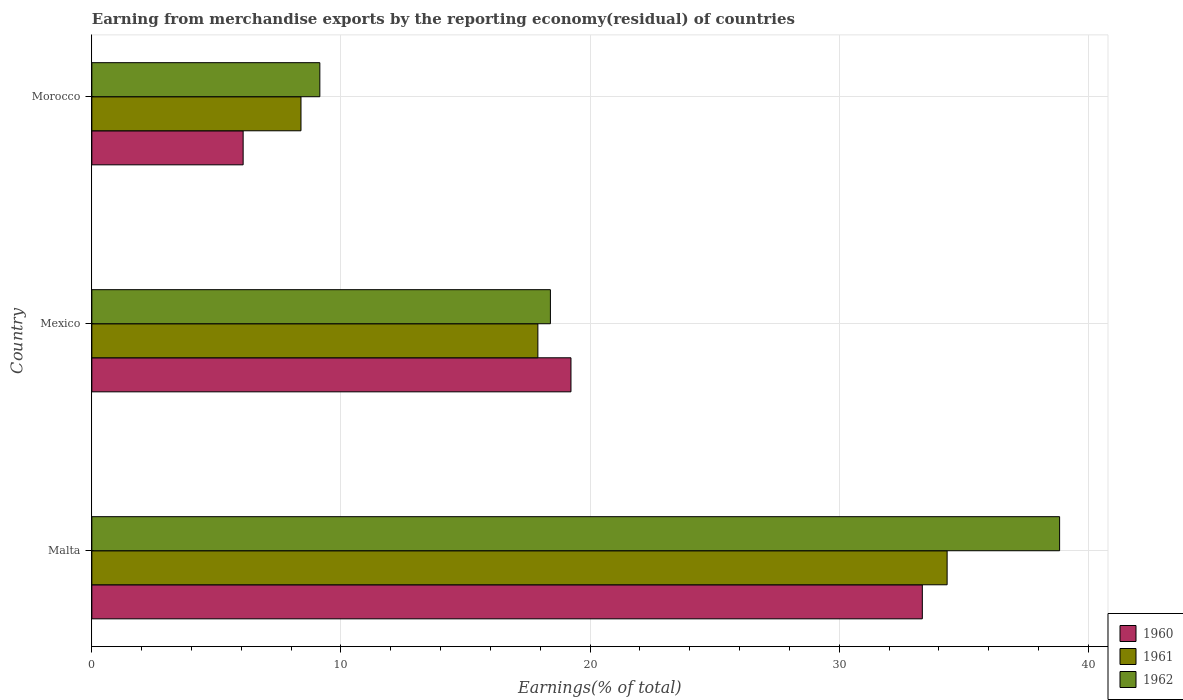How many different coloured bars are there?
Your answer should be compact. 3. Are the number of bars per tick equal to the number of legend labels?
Your answer should be very brief. Yes. Are the number of bars on each tick of the Y-axis equal?
Your answer should be compact. Yes. How many bars are there on the 1st tick from the bottom?
Keep it short and to the point. 3. What is the label of the 3rd group of bars from the top?
Give a very brief answer. Malta. In how many cases, is the number of bars for a given country not equal to the number of legend labels?
Provide a short and direct response. 0. What is the percentage of amount earned from merchandise exports in 1961 in Morocco?
Offer a very short reply. 8.39. Across all countries, what is the maximum percentage of amount earned from merchandise exports in 1960?
Your response must be concise. 33.33. Across all countries, what is the minimum percentage of amount earned from merchandise exports in 1962?
Keep it short and to the point. 9.15. In which country was the percentage of amount earned from merchandise exports in 1960 maximum?
Your answer should be very brief. Malta. In which country was the percentage of amount earned from merchandise exports in 1961 minimum?
Keep it short and to the point. Morocco. What is the total percentage of amount earned from merchandise exports in 1960 in the graph?
Ensure brevity in your answer.  58.64. What is the difference between the percentage of amount earned from merchandise exports in 1960 in Mexico and that in Morocco?
Your response must be concise. 13.16. What is the difference between the percentage of amount earned from merchandise exports in 1962 in Malta and the percentage of amount earned from merchandise exports in 1960 in Morocco?
Your answer should be compact. 32.77. What is the average percentage of amount earned from merchandise exports in 1961 per country?
Ensure brevity in your answer.  20.21. What is the difference between the percentage of amount earned from merchandise exports in 1962 and percentage of amount earned from merchandise exports in 1960 in Malta?
Keep it short and to the point. 5.51. In how many countries, is the percentage of amount earned from merchandise exports in 1961 greater than 30 %?
Your response must be concise. 1. What is the ratio of the percentage of amount earned from merchandise exports in 1961 in Mexico to that in Morocco?
Your answer should be compact. 2.13. Is the percentage of amount earned from merchandise exports in 1961 in Malta less than that in Mexico?
Your response must be concise. No. Is the difference between the percentage of amount earned from merchandise exports in 1962 in Malta and Morocco greater than the difference between the percentage of amount earned from merchandise exports in 1960 in Malta and Morocco?
Your answer should be very brief. Yes. What is the difference between the highest and the second highest percentage of amount earned from merchandise exports in 1962?
Offer a terse response. 20.44. What is the difference between the highest and the lowest percentage of amount earned from merchandise exports in 1960?
Provide a succinct answer. 27.26. What does the 2nd bar from the bottom in Mexico represents?
Keep it short and to the point. 1961. How many countries are there in the graph?
Provide a succinct answer. 3. What is the difference between two consecutive major ticks on the X-axis?
Keep it short and to the point. 10. Does the graph contain any zero values?
Make the answer very short. No. Does the graph contain grids?
Offer a very short reply. Yes. Where does the legend appear in the graph?
Your answer should be very brief. Bottom right. How are the legend labels stacked?
Ensure brevity in your answer.  Vertical. What is the title of the graph?
Offer a very short reply. Earning from merchandise exports by the reporting economy(residual) of countries. What is the label or title of the X-axis?
Your answer should be very brief. Earnings(% of total). What is the label or title of the Y-axis?
Your answer should be compact. Country. What is the Earnings(% of total) of 1960 in Malta?
Give a very brief answer. 33.33. What is the Earnings(% of total) in 1961 in Malta?
Your answer should be compact. 34.33. What is the Earnings(% of total) of 1962 in Malta?
Provide a succinct answer. 38.84. What is the Earnings(% of total) of 1960 in Mexico?
Your answer should be very brief. 19.23. What is the Earnings(% of total) in 1961 in Mexico?
Offer a very short reply. 17.9. What is the Earnings(% of total) of 1962 in Mexico?
Provide a succinct answer. 18.41. What is the Earnings(% of total) in 1960 in Morocco?
Provide a short and direct response. 6.07. What is the Earnings(% of total) of 1961 in Morocco?
Offer a very short reply. 8.39. What is the Earnings(% of total) in 1962 in Morocco?
Keep it short and to the point. 9.15. Across all countries, what is the maximum Earnings(% of total) of 1960?
Provide a succinct answer. 33.33. Across all countries, what is the maximum Earnings(% of total) in 1961?
Give a very brief answer. 34.33. Across all countries, what is the maximum Earnings(% of total) of 1962?
Your answer should be compact. 38.84. Across all countries, what is the minimum Earnings(% of total) in 1960?
Give a very brief answer. 6.07. Across all countries, what is the minimum Earnings(% of total) of 1961?
Your answer should be compact. 8.39. Across all countries, what is the minimum Earnings(% of total) in 1962?
Offer a terse response. 9.15. What is the total Earnings(% of total) in 1960 in the graph?
Provide a short and direct response. 58.64. What is the total Earnings(% of total) in 1961 in the graph?
Make the answer very short. 60.62. What is the total Earnings(% of total) of 1962 in the graph?
Offer a very short reply. 66.4. What is the difference between the Earnings(% of total) in 1960 in Malta and that in Mexico?
Keep it short and to the point. 14.1. What is the difference between the Earnings(% of total) of 1961 in Malta and that in Mexico?
Provide a short and direct response. 16.43. What is the difference between the Earnings(% of total) in 1962 in Malta and that in Mexico?
Offer a very short reply. 20.44. What is the difference between the Earnings(% of total) of 1960 in Malta and that in Morocco?
Provide a short and direct response. 27.26. What is the difference between the Earnings(% of total) of 1961 in Malta and that in Morocco?
Offer a very short reply. 25.93. What is the difference between the Earnings(% of total) of 1962 in Malta and that in Morocco?
Provide a short and direct response. 29.69. What is the difference between the Earnings(% of total) of 1960 in Mexico and that in Morocco?
Your answer should be very brief. 13.16. What is the difference between the Earnings(% of total) of 1961 in Mexico and that in Morocco?
Offer a very short reply. 9.51. What is the difference between the Earnings(% of total) of 1962 in Mexico and that in Morocco?
Your response must be concise. 9.25. What is the difference between the Earnings(% of total) of 1960 in Malta and the Earnings(% of total) of 1961 in Mexico?
Make the answer very short. 15.43. What is the difference between the Earnings(% of total) of 1960 in Malta and the Earnings(% of total) of 1962 in Mexico?
Provide a succinct answer. 14.93. What is the difference between the Earnings(% of total) in 1961 in Malta and the Earnings(% of total) in 1962 in Mexico?
Keep it short and to the point. 15.92. What is the difference between the Earnings(% of total) of 1960 in Malta and the Earnings(% of total) of 1961 in Morocco?
Your answer should be compact. 24.94. What is the difference between the Earnings(% of total) in 1960 in Malta and the Earnings(% of total) in 1962 in Morocco?
Provide a succinct answer. 24.18. What is the difference between the Earnings(% of total) of 1961 in Malta and the Earnings(% of total) of 1962 in Morocco?
Give a very brief answer. 25.18. What is the difference between the Earnings(% of total) of 1960 in Mexico and the Earnings(% of total) of 1961 in Morocco?
Offer a very short reply. 10.84. What is the difference between the Earnings(% of total) in 1960 in Mexico and the Earnings(% of total) in 1962 in Morocco?
Keep it short and to the point. 10.08. What is the difference between the Earnings(% of total) of 1961 in Mexico and the Earnings(% of total) of 1962 in Morocco?
Ensure brevity in your answer.  8.75. What is the average Earnings(% of total) in 1960 per country?
Your answer should be very brief. 19.55. What is the average Earnings(% of total) in 1961 per country?
Your answer should be compact. 20.21. What is the average Earnings(% of total) of 1962 per country?
Give a very brief answer. 22.13. What is the difference between the Earnings(% of total) of 1960 and Earnings(% of total) of 1961 in Malta?
Keep it short and to the point. -0.99. What is the difference between the Earnings(% of total) in 1960 and Earnings(% of total) in 1962 in Malta?
Offer a very short reply. -5.51. What is the difference between the Earnings(% of total) in 1961 and Earnings(% of total) in 1962 in Malta?
Provide a short and direct response. -4.51. What is the difference between the Earnings(% of total) of 1960 and Earnings(% of total) of 1961 in Mexico?
Ensure brevity in your answer.  1.33. What is the difference between the Earnings(% of total) of 1960 and Earnings(% of total) of 1962 in Mexico?
Your answer should be compact. 0.83. What is the difference between the Earnings(% of total) of 1961 and Earnings(% of total) of 1962 in Mexico?
Your answer should be very brief. -0.5. What is the difference between the Earnings(% of total) of 1960 and Earnings(% of total) of 1961 in Morocco?
Offer a terse response. -2.32. What is the difference between the Earnings(% of total) of 1960 and Earnings(% of total) of 1962 in Morocco?
Your answer should be very brief. -3.08. What is the difference between the Earnings(% of total) in 1961 and Earnings(% of total) in 1962 in Morocco?
Your response must be concise. -0.76. What is the ratio of the Earnings(% of total) in 1960 in Malta to that in Mexico?
Offer a terse response. 1.73. What is the ratio of the Earnings(% of total) of 1961 in Malta to that in Mexico?
Make the answer very short. 1.92. What is the ratio of the Earnings(% of total) of 1962 in Malta to that in Mexico?
Give a very brief answer. 2.11. What is the ratio of the Earnings(% of total) of 1960 in Malta to that in Morocco?
Keep it short and to the point. 5.49. What is the ratio of the Earnings(% of total) in 1961 in Malta to that in Morocco?
Offer a very short reply. 4.09. What is the ratio of the Earnings(% of total) in 1962 in Malta to that in Morocco?
Keep it short and to the point. 4.24. What is the ratio of the Earnings(% of total) of 1960 in Mexico to that in Morocco?
Your answer should be compact. 3.17. What is the ratio of the Earnings(% of total) of 1961 in Mexico to that in Morocco?
Provide a short and direct response. 2.13. What is the ratio of the Earnings(% of total) in 1962 in Mexico to that in Morocco?
Ensure brevity in your answer.  2.01. What is the difference between the highest and the second highest Earnings(% of total) in 1960?
Ensure brevity in your answer.  14.1. What is the difference between the highest and the second highest Earnings(% of total) in 1961?
Offer a terse response. 16.43. What is the difference between the highest and the second highest Earnings(% of total) of 1962?
Your answer should be very brief. 20.44. What is the difference between the highest and the lowest Earnings(% of total) in 1960?
Ensure brevity in your answer.  27.26. What is the difference between the highest and the lowest Earnings(% of total) of 1961?
Your answer should be very brief. 25.93. What is the difference between the highest and the lowest Earnings(% of total) of 1962?
Your answer should be compact. 29.69. 